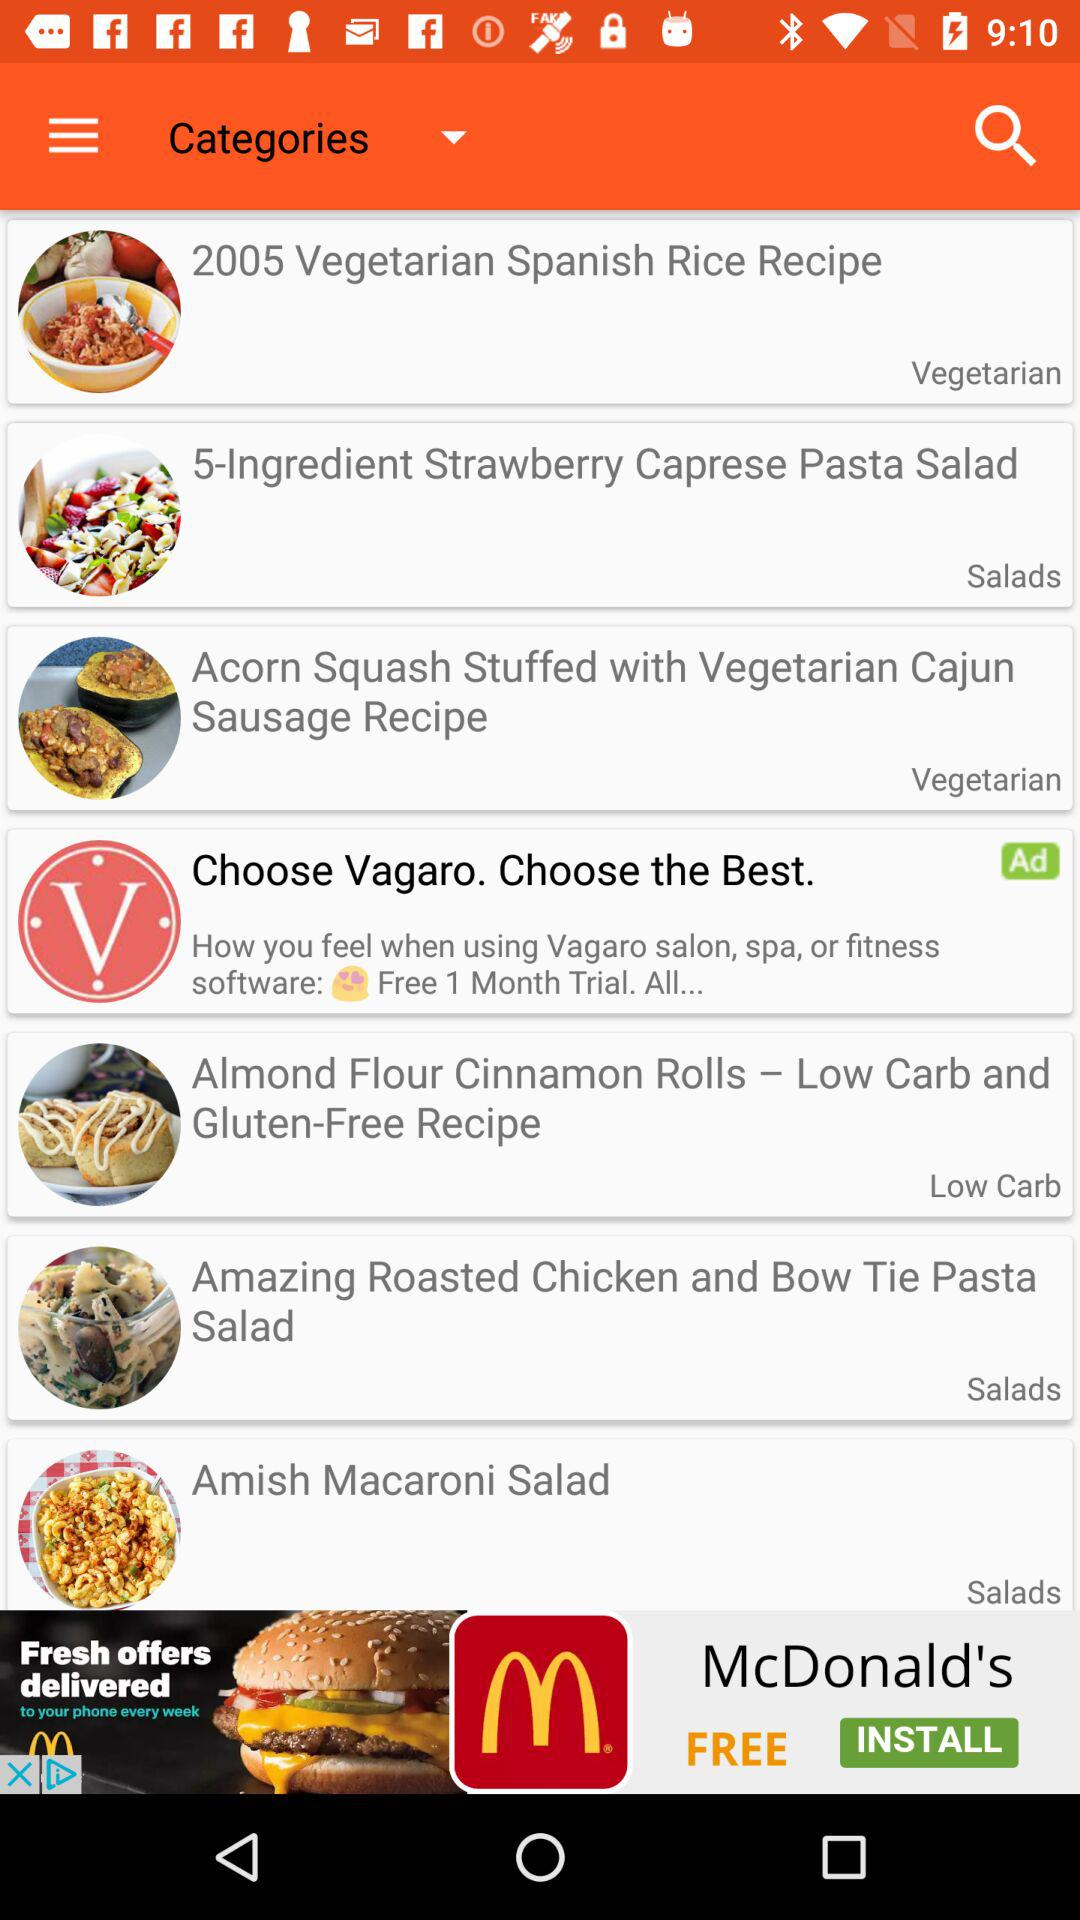How many types of recipes are available?
When the provided information is insufficient, respond with <no answer>. <no answer> 